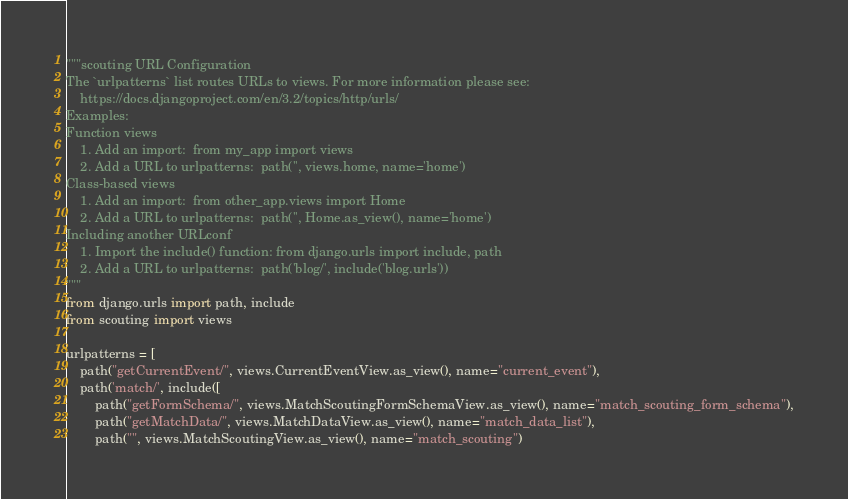<code> <loc_0><loc_0><loc_500><loc_500><_Python_>"""scouting URL Configuration
The `urlpatterns` list routes URLs to views. For more information please see:
    https://docs.djangoproject.com/en/3.2/topics/http/urls/
Examples:
Function views
    1. Add an import:  from my_app import views
    2. Add a URL to urlpatterns:  path('', views.home, name='home')
Class-based views
    1. Add an import:  from other_app.views import Home
    2. Add a URL to urlpatterns:  path('', Home.as_view(), name='home')
Including another URLconf
    1. Import the include() function: from django.urls import include, path
    2. Add a URL to urlpatterns:  path('blog/', include('blog.urls'))
"""
from django.urls import path, include
from scouting import views

urlpatterns = [
    path("getCurrentEvent/", views.CurrentEventView.as_view(), name="current_event"),
    path('match/', include([
        path("getFormSchema/", views.MatchScoutingFormSchemaView.as_view(), name="match_scouting_form_schema"),
        path("getMatchData/", views.MatchDataView.as_view(), name="match_data_list"),
        path("", views.MatchScoutingView.as_view(), name="match_scouting")</code> 